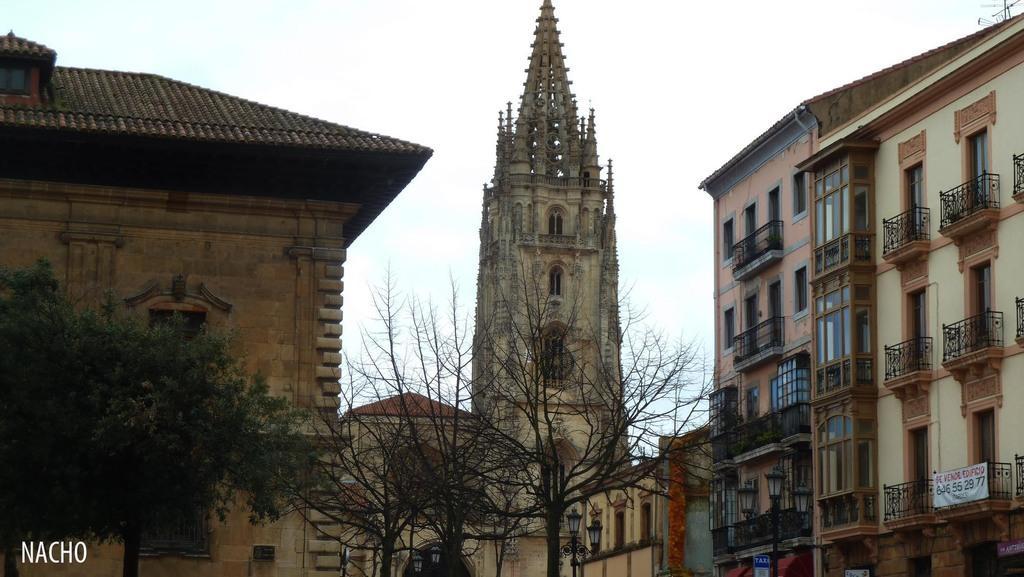Could you give a brief overview of what you see in this image? In this picture we can see buildings and trees. At the top of the image, there is the sky. At the bottom of the image, there is a pole with lights attached to it. On the right side of the image, there is a banner. In the bottom left corner of the image, there is a watermark. 